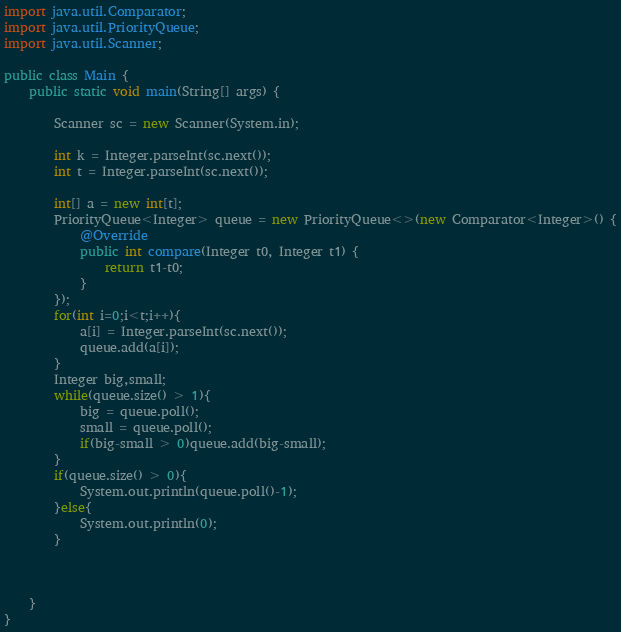<code> <loc_0><loc_0><loc_500><loc_500><_Java_>
import java.util.Comparator;
import java.util.PriorityQueue;
import java.util.Scanner;

public class Main {
    public static void main(String[] args) {

        Scanner sc = new Scanner(System.in);

        int k = Integer.parseInt(sc.next());
        int t = Integer.parseInt(sc.next());

        int[] a = new int[t];
        PriorityQueue<Integer> queue = new PriorityQueue<>(new Comparator<Integer>() {
            @Override
            public int compare(Integer t0, Integer t1) {
                return t1-t0;
            }
        });
        for(int i=0;i<t;i++){
            a[i] = Integer.parseInt(sc.next());
            queue.add(a[i]);
        }
        Integer big,small;
        while(queue.size() > 1){
            big = queue.poll();
            small = queue.poll();
            if(big-small > 0)queue.add(big-small);
        }
        if(queue.size() > 0){
            System.out.println(queue.poll()-1);
        }else{
            System.out.println(0);
        }
        


    }
}
</code> 